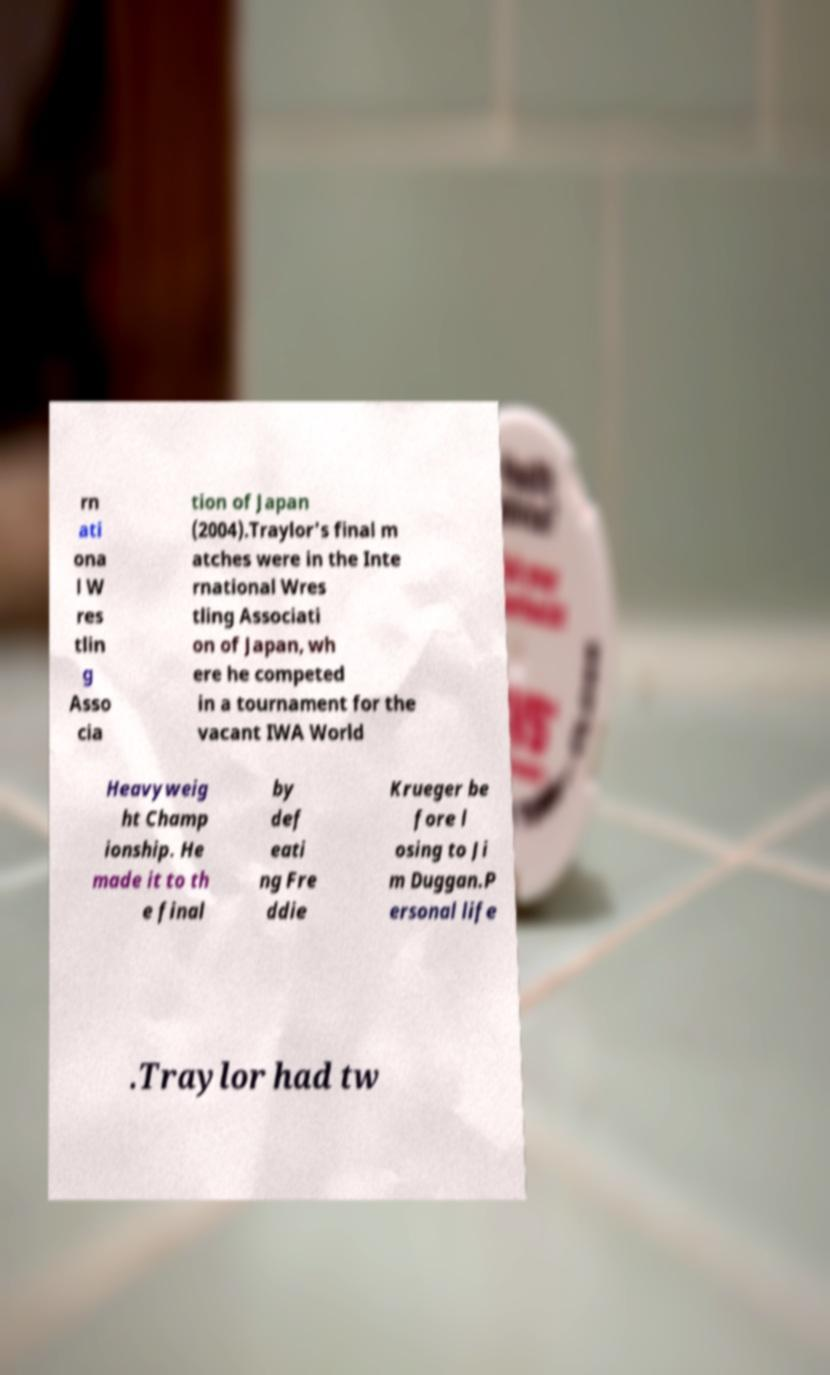Could you extract and type out the text from this image? rn ati ona l W res tlin g Asso cia tion of Japan (2004).Traylor's final m atches were in the Inte rnational Wres tling Associati on of Japan, wh ere he competed in a tournament for the vacant IWA World Heavyweig ht Champ ionship. He made it to th e final by def eati ng Fre ddie Krueger be fore l osing to Ji m Duggan.P ersonal life .Traylor had tw 